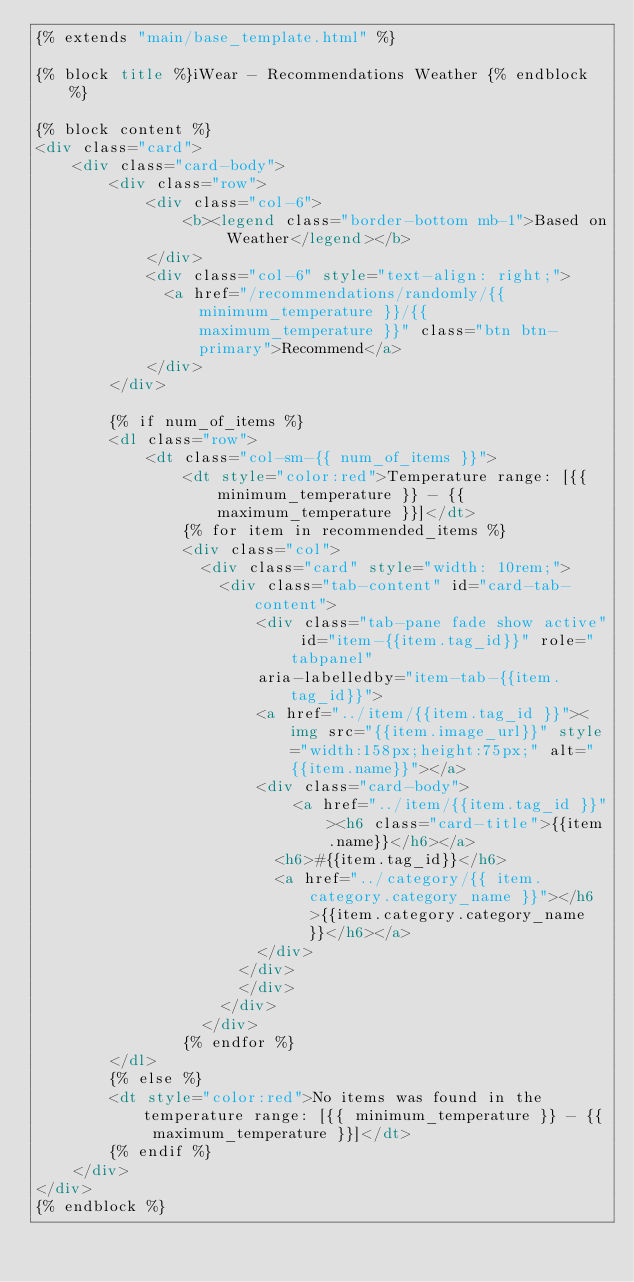<code> <loc_0><loc_0><loc_500><loc_500><_HTML_>{% extends "main/base_template.html" %}

{% block title %}iWear - Recommendations Weather {% endblock %}

{% block content %}
<div class="card">
    <div class="card-body">
        <div class="row">
            <div class="col-6">
                <b><legend class="border-bottom mb-1">Based on Weather</legend></b>
            </div>
            <div class="col-6" style="text-align: right;">
              <a href="/recommendations/randomly/{{ minimum_temperature }}/{{ maximum_temperature }}" class="btn btn-primary">Recommend</a> 
            </div>
        </div>

        {% if num_of_items %}
        <dl class="row">
            <dt class="col-sm-{{ num_of_items }}">
                <dt style="color:red">Temperature range: [{{ minimum_temperature }} - {{ maximum_temperature }}]</dt>
                {% for item in recommended_items %}
                <div class="col">
                  <div class="card" style="width: 10rem;">
                    <div class="tab-content" id="card-tab-content">
                        <div class="tab-pane fade show active" id="item-{{item.tag_id}}" role="tabpanel"
                        aria-labelledby="item-tab-{{item.tag_id}}">
                        <a href="../item/{{item.tag_id }}"><img src="{{item.image_url}}" style="width:158px;height:75px;" alt="{{item.name}}"></a>
                        <div class="card-body">
                            <a href="../item/{{item.tag_id }}"><h6 class="card-title">{{item.name}}</h6></a>
                          <h6>#{{item.tag_id}}</h6>
                          <a href="../category/{{ item.category.category_name }}"></h6>{{item.category.category_name}}</h6></a>
                        </div>
                      </div>
                      </div>
                    </div>
                  </div>
                {% endfor %}
        </dl>
        {% else %}
        <dt style="color:red">No items was found in the temperature range: [{{ minimum_temperature }} - {{ maximum_temperature }}]</dt>
        {% endif %}
    </div>
</div>
{% endblock %}

</code> 